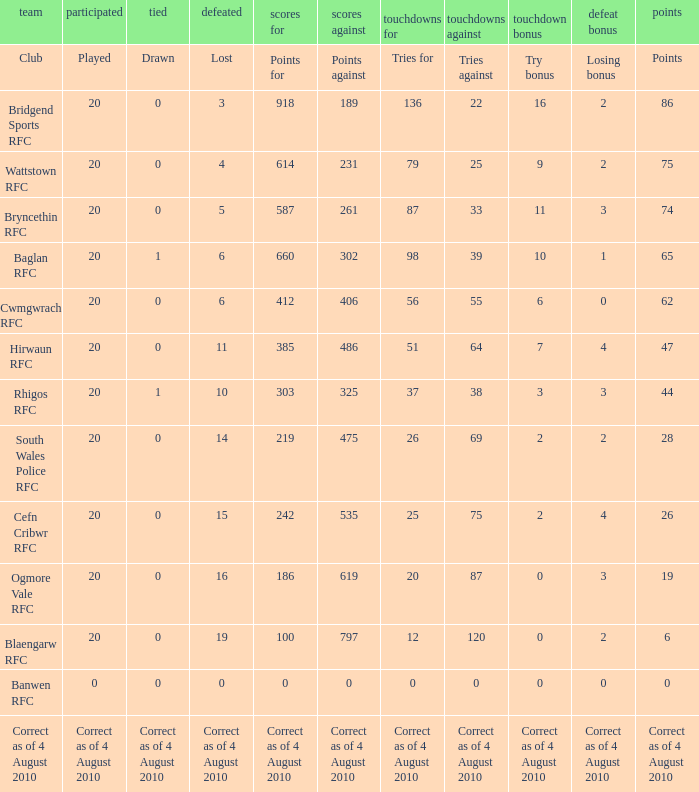When the points against amount to 231, what is lost? 4.0. 